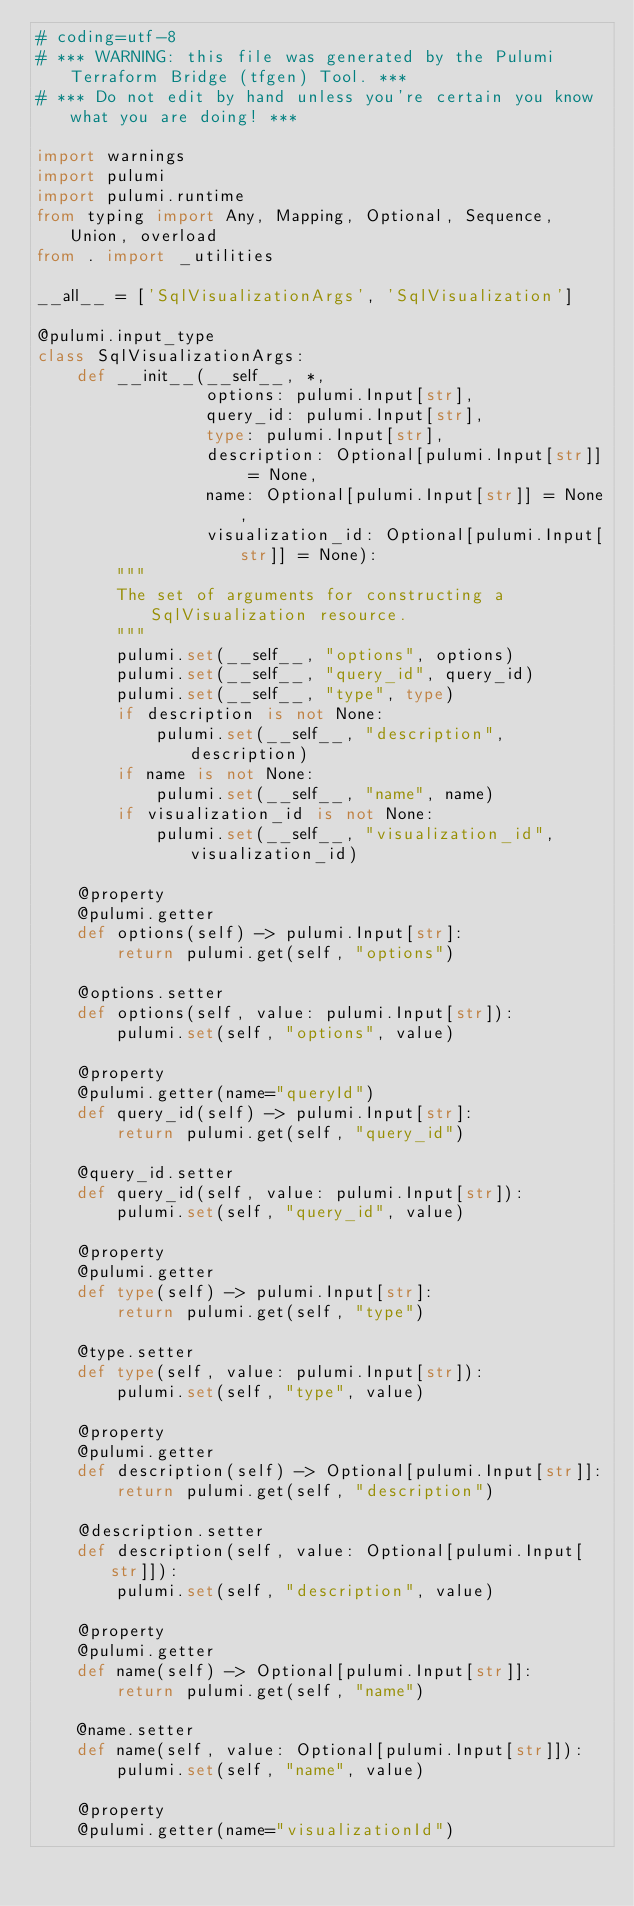<code> <loc_0><loc_0><loc_500><loc_500><_Python_># coding=utf-8
# *** WARNING: this file was generated by the Pulumi Terraform Bridge (tfgen) Tool. ***
# *** Do not edit by hand unless you're certain you know what you are doing! ***

import warnings
import pulumi
import pulumi.runtime
from typing import Any, Mapping, Optional, Sequence, Union, overload
from . import _utilities

__all__ = ['SqlVisualizationArgs', 'SqlVisualization']

@pulumi.input_type
class SqlVisualizationArgs:
    def __init__(__self__, *,
                 options: pulumi.Input[str],
                 query_id: pulumi.Input[str],
                 type: pulumi.Input[str],
                 description: Optional[pulumi.Input[str]] = None,
                 name: Optional[pulumi.Input[str]] = None,
                 visualization_id: Optional[pulumi.Input[str]] = None):
        """
        The set of arguments for constructing a SqlVisualization resource.
        """
        pulumi.set(__self__, "options", options)
        pulumi.set(__self__, "query_id", query_id)
        pulumi.set(__self__, "type", type)
        if description is not None:
            pulumi.set(__self__, "description", description)
        if name is not None:
            pulumi.set(__self__, "name", name)
        if visualization_id is not None:
            pulumi.set(__self__, "visualization_id", visualization_id)

    @property
    @pulumi.getter
    def options(self) -> pulumi.Input[str]:
        return pulumi.get(self, "options")

    @options.setter
    def options(self, value: pulumi.Input[str]):
        pulumi.set(self, "options", value)

    @property
    @pulumi.getter(name="queryId")
    def query_id(self) -> pulumi.Input[str]:
        return pulumi.get(self, "query_id")

    @query_id.setter
    def query_id(self, value: pulumi.Input[str]):
        pulumi.set(self, "query_id", value)

    @property
    @pulumi.getter
    def type(self) -> pulumi.Input[str]:
        return pulumi.get(self, "type")

    @type.setter
    def type(self, value: pulumi.Input[str]):
        pulumi.set(self, "type", value)

    @property
    @pulumi.getter
    def description(self) -> Optional[pulumi.Input[str]]:
        return pulumi.get(self, "description")

    @description.setter
    def description(self, value: Optional[pulumi.Input[str]]):
        pulumi.set(self, "description", value)

    @property
    @pulumi.getter
    def name(self) -> Optional[pulumi.Input[str]]:
        return pulumi.get(self, "name")

    @name.setter
    def name(self, value: Optional[pulumi.Input[str]]):
        pulumi.set(self, "name", value)

    @property
    @pulumi.getter(name="visualizationId")</code> 